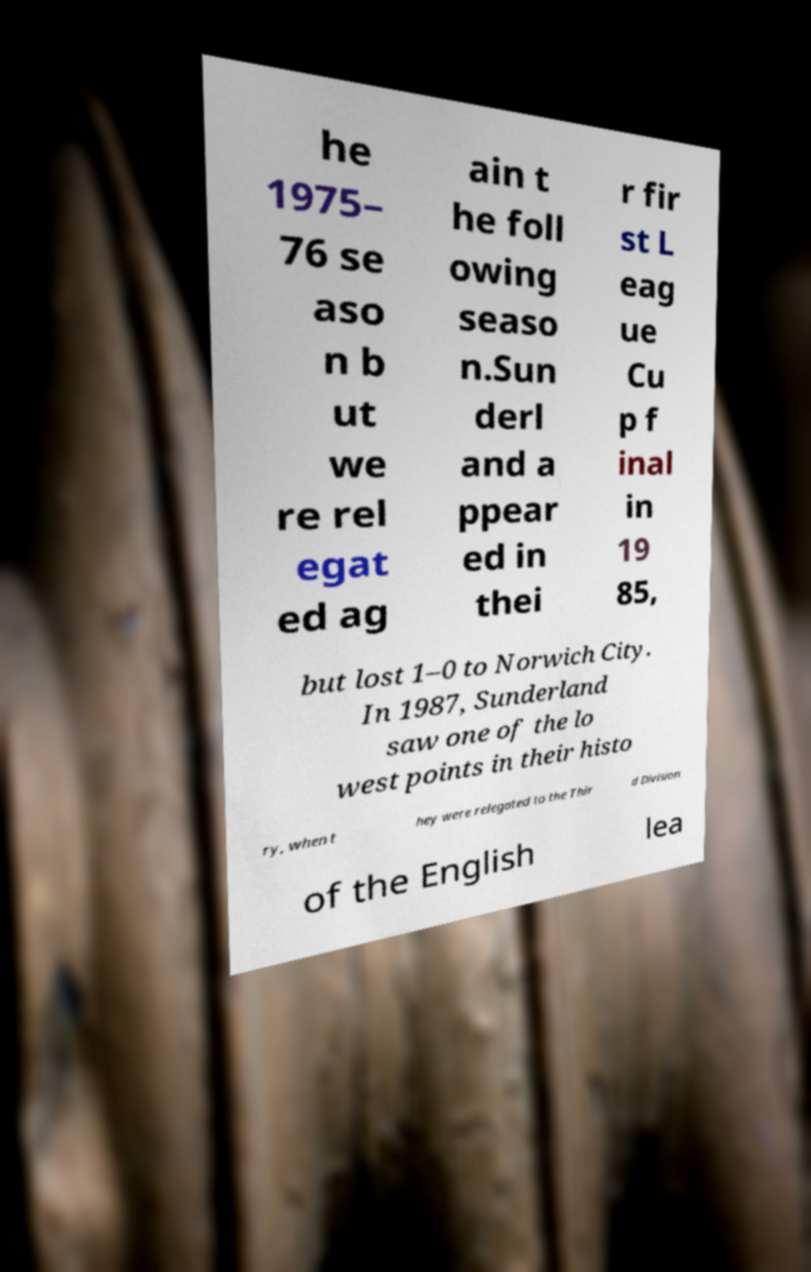For documentation purposes, I need the text within this image transcribed. Could you provide that? he 1975– 76 se aso n b ut we re rel egat ed ag ain t he foll owing seaso n.Sun derl and a ppear ed in thei r fir st L eag ue Cu p f inal in 19 85, but lost 1–0 to Norwich City. In 1987, Sunderland saw one of the lo west points in their histo ry, when t hey were relegated to the Thir d Division of the English lea 